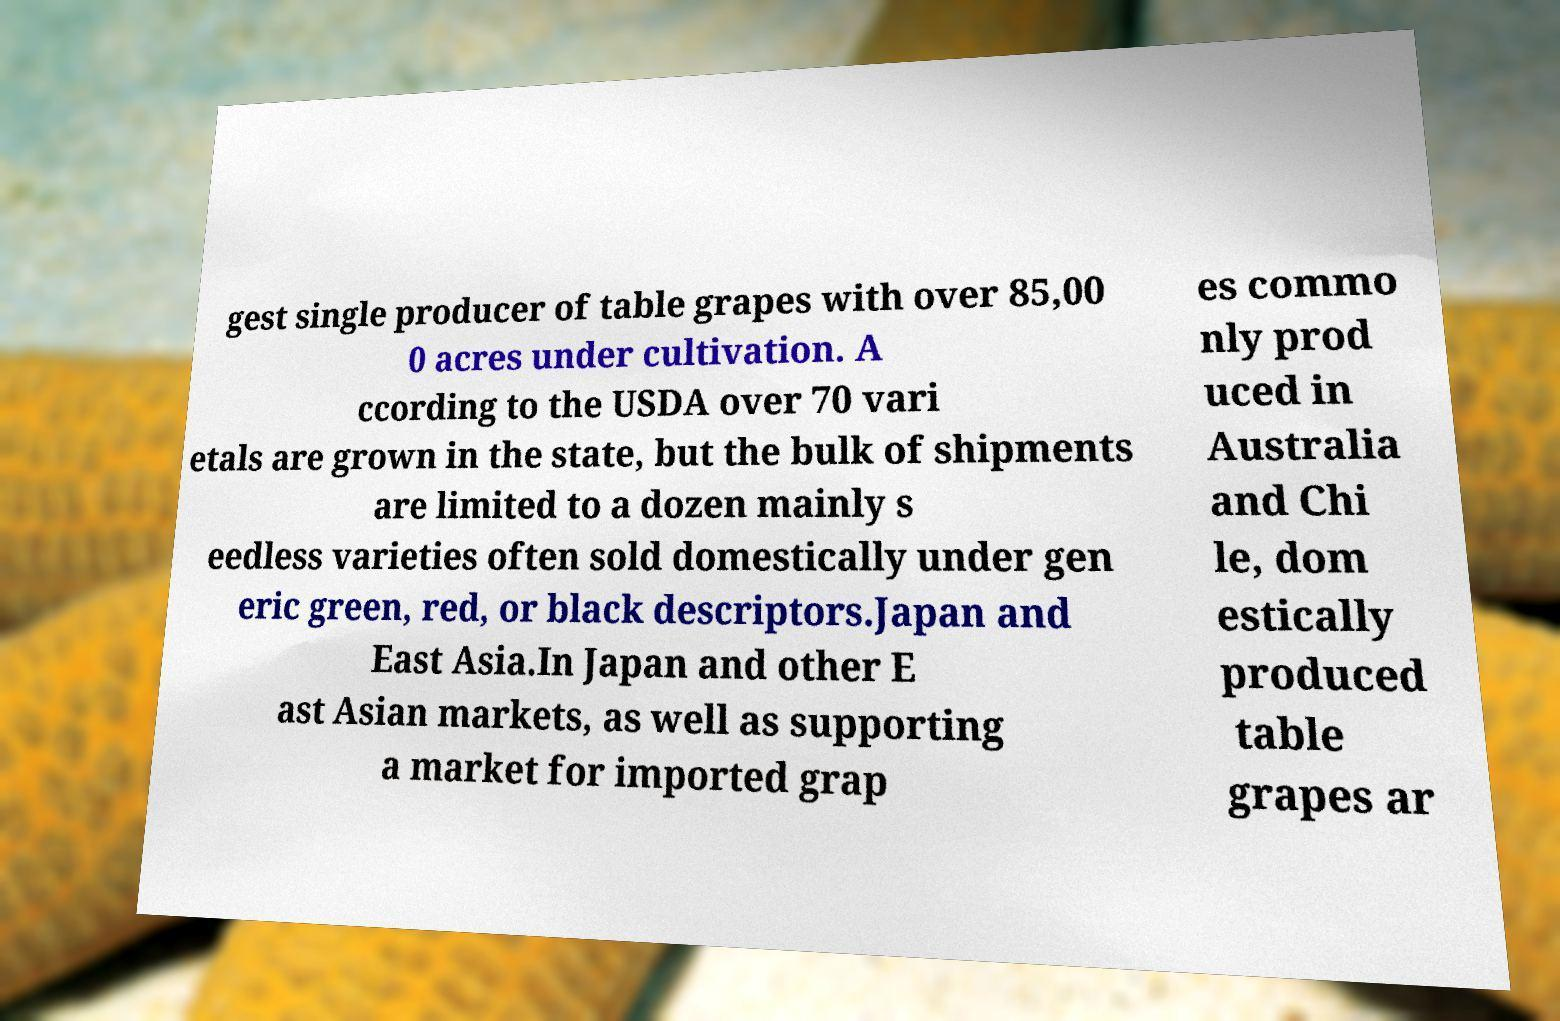Can you read and provide the text displayed in the image?This photo seems to have some interesting text. Can you extract and type it out for me? gest single producer of table grapes with over 85,00 0 acres under cultivation. A ccording to the USDA over 70 vari etals are grown in the state, but the bulk of shipments are limited to a dozen mainly s eedless varieties often sold domestically under gen eric green, red, or black descriptors.Japan and East Asia.In Japan and other E ast Asian markets, as well as supporting a market for imported grap es commo nly prod uced in Australia and Chi le, dom estically produced table grapes ar 